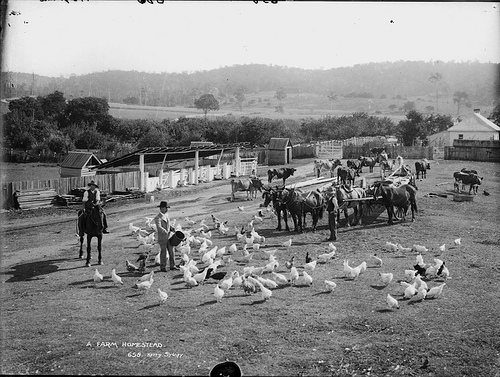What do these birds produce? These birds, which are commonly known as chickens, are prolific producers of eggs, a staple food rich in protein and versatile in cooking. 